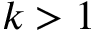Convert formula to latex. <formula><loc_0><loc_0><loc_500><loc_500>k > 1</formula> 